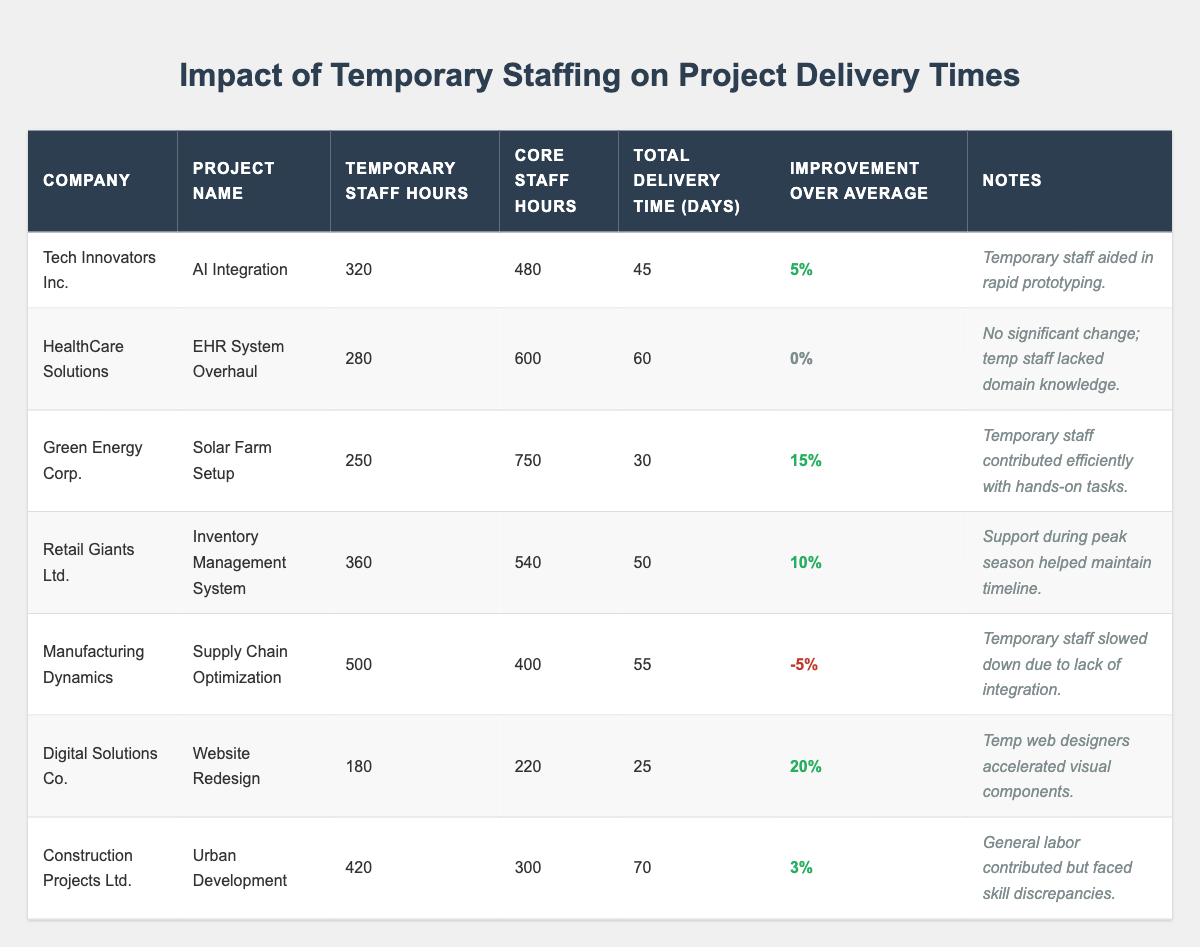What is the project with the longest total delivery time? The project with the longest total delivery time listed in the table is "Urban Development," which took 70 days to complete.
Answer: Urban Development How many hours of temporary staff were used in the "Solar Farm Setup" project? The "Solar Farm Setup" project had 250 hours of temporary staff.
Answer: 250 Which project had a delivery time improvement of 20%? The "Website Redesign" project had a delivery time improvement of 20%, indicating that the temporary staff significantly contributed to its efficiency.
Answer: Website Redesign What is the average delivery time for all projects listed in the table? The total delivery times of the projects are 45, 60, 30, 50, 55, 25, and 70 days. Summing these gives 335 days. There are 7 projects, so the average is 335/7 = 47.86 days, rounded to 48 days.
Answer: 48 days Was the use of temporary staff beneficial for "Supply Chain Optimization"? The "Supply Chain Optimization" project showed a negative improvement of -5%, indicating that the use of temporary staff was not beneficial in this case.
Answer: No Which two projects had the highest and lowest temporary staff hours? "Supply Chain Optimization" had the highest temporary staff hours at 500, while "Website Redesign" had the lowest at 180.
Answer: Supply Chain Optimization and Website Redesign Did any project achieve an improvement over the average delivery time greater than 10%? Yes, the "Solar Farm Setup" and "Website Redesign" projects achieved improvements over the average delivery time that were greater than 10%, with 15% and 20% respectively.
Answer: Yes How many projects had an improvement over average delivery times? There are four projects ("AI Integration," "Solar Farm Setup," "Inventory Management System," and "Website Redesign") that showed an improvement over average delivery times.
Answer: Four projects What is the combined total of core staff hours across all projects? The total core staff hours are 480 + 600 + 750 + 540 + 400 + 220 + 300, which sums to 3290 hours.
Answer: 3290 hours For which project was the temporary staff's lack of domain knowledge noted as an issue? The "EHR System Overhaul" project noted that the temporary staff lacked domain knowledge, leading to no significant change in delivery time.
Answer: EHR System Overhaul 